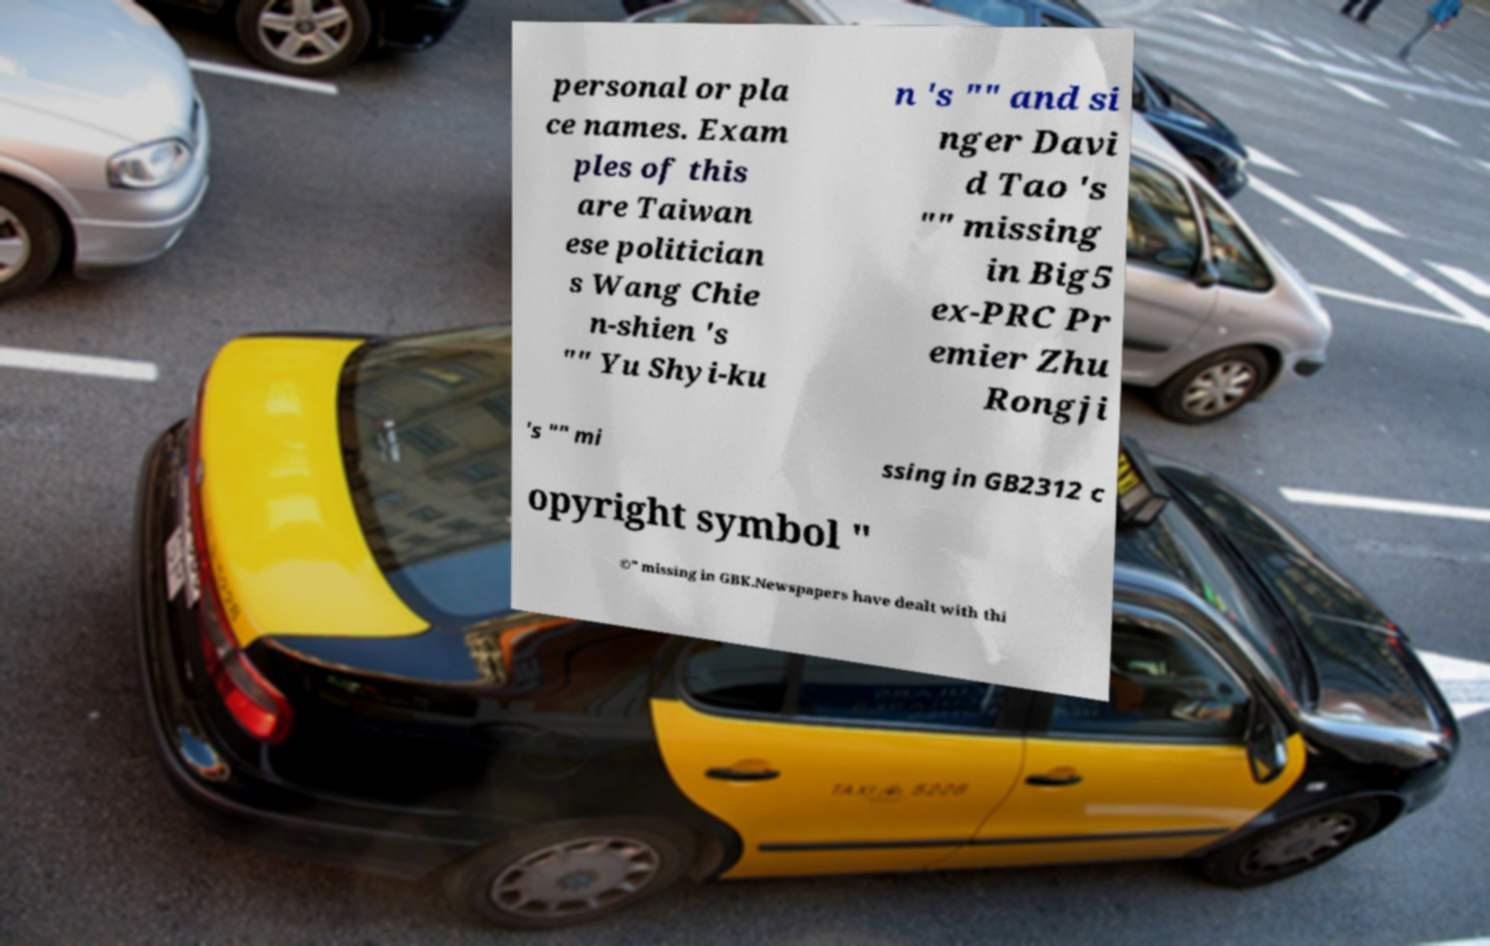Please identify and transcribe the text found in this image. personal or pla ce names. Exam ples of this are Taiwan ese politician s Wang Chie n-shien 's "" Yu Shyi-ku n 's "" and si nger Davi d Tao 's "" missing in Big5 ex-PRC Pr emier Zhu Rongji 's "" mi ssing in GB2312 c opyright symbol " ©" missing in GBK.Newspapers have dealt with thi 